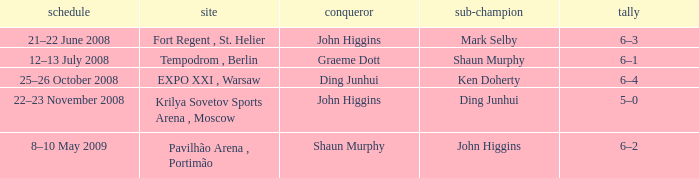Who was the winner in the match that had John Higgins as runner-up? Shaun Murphy. 